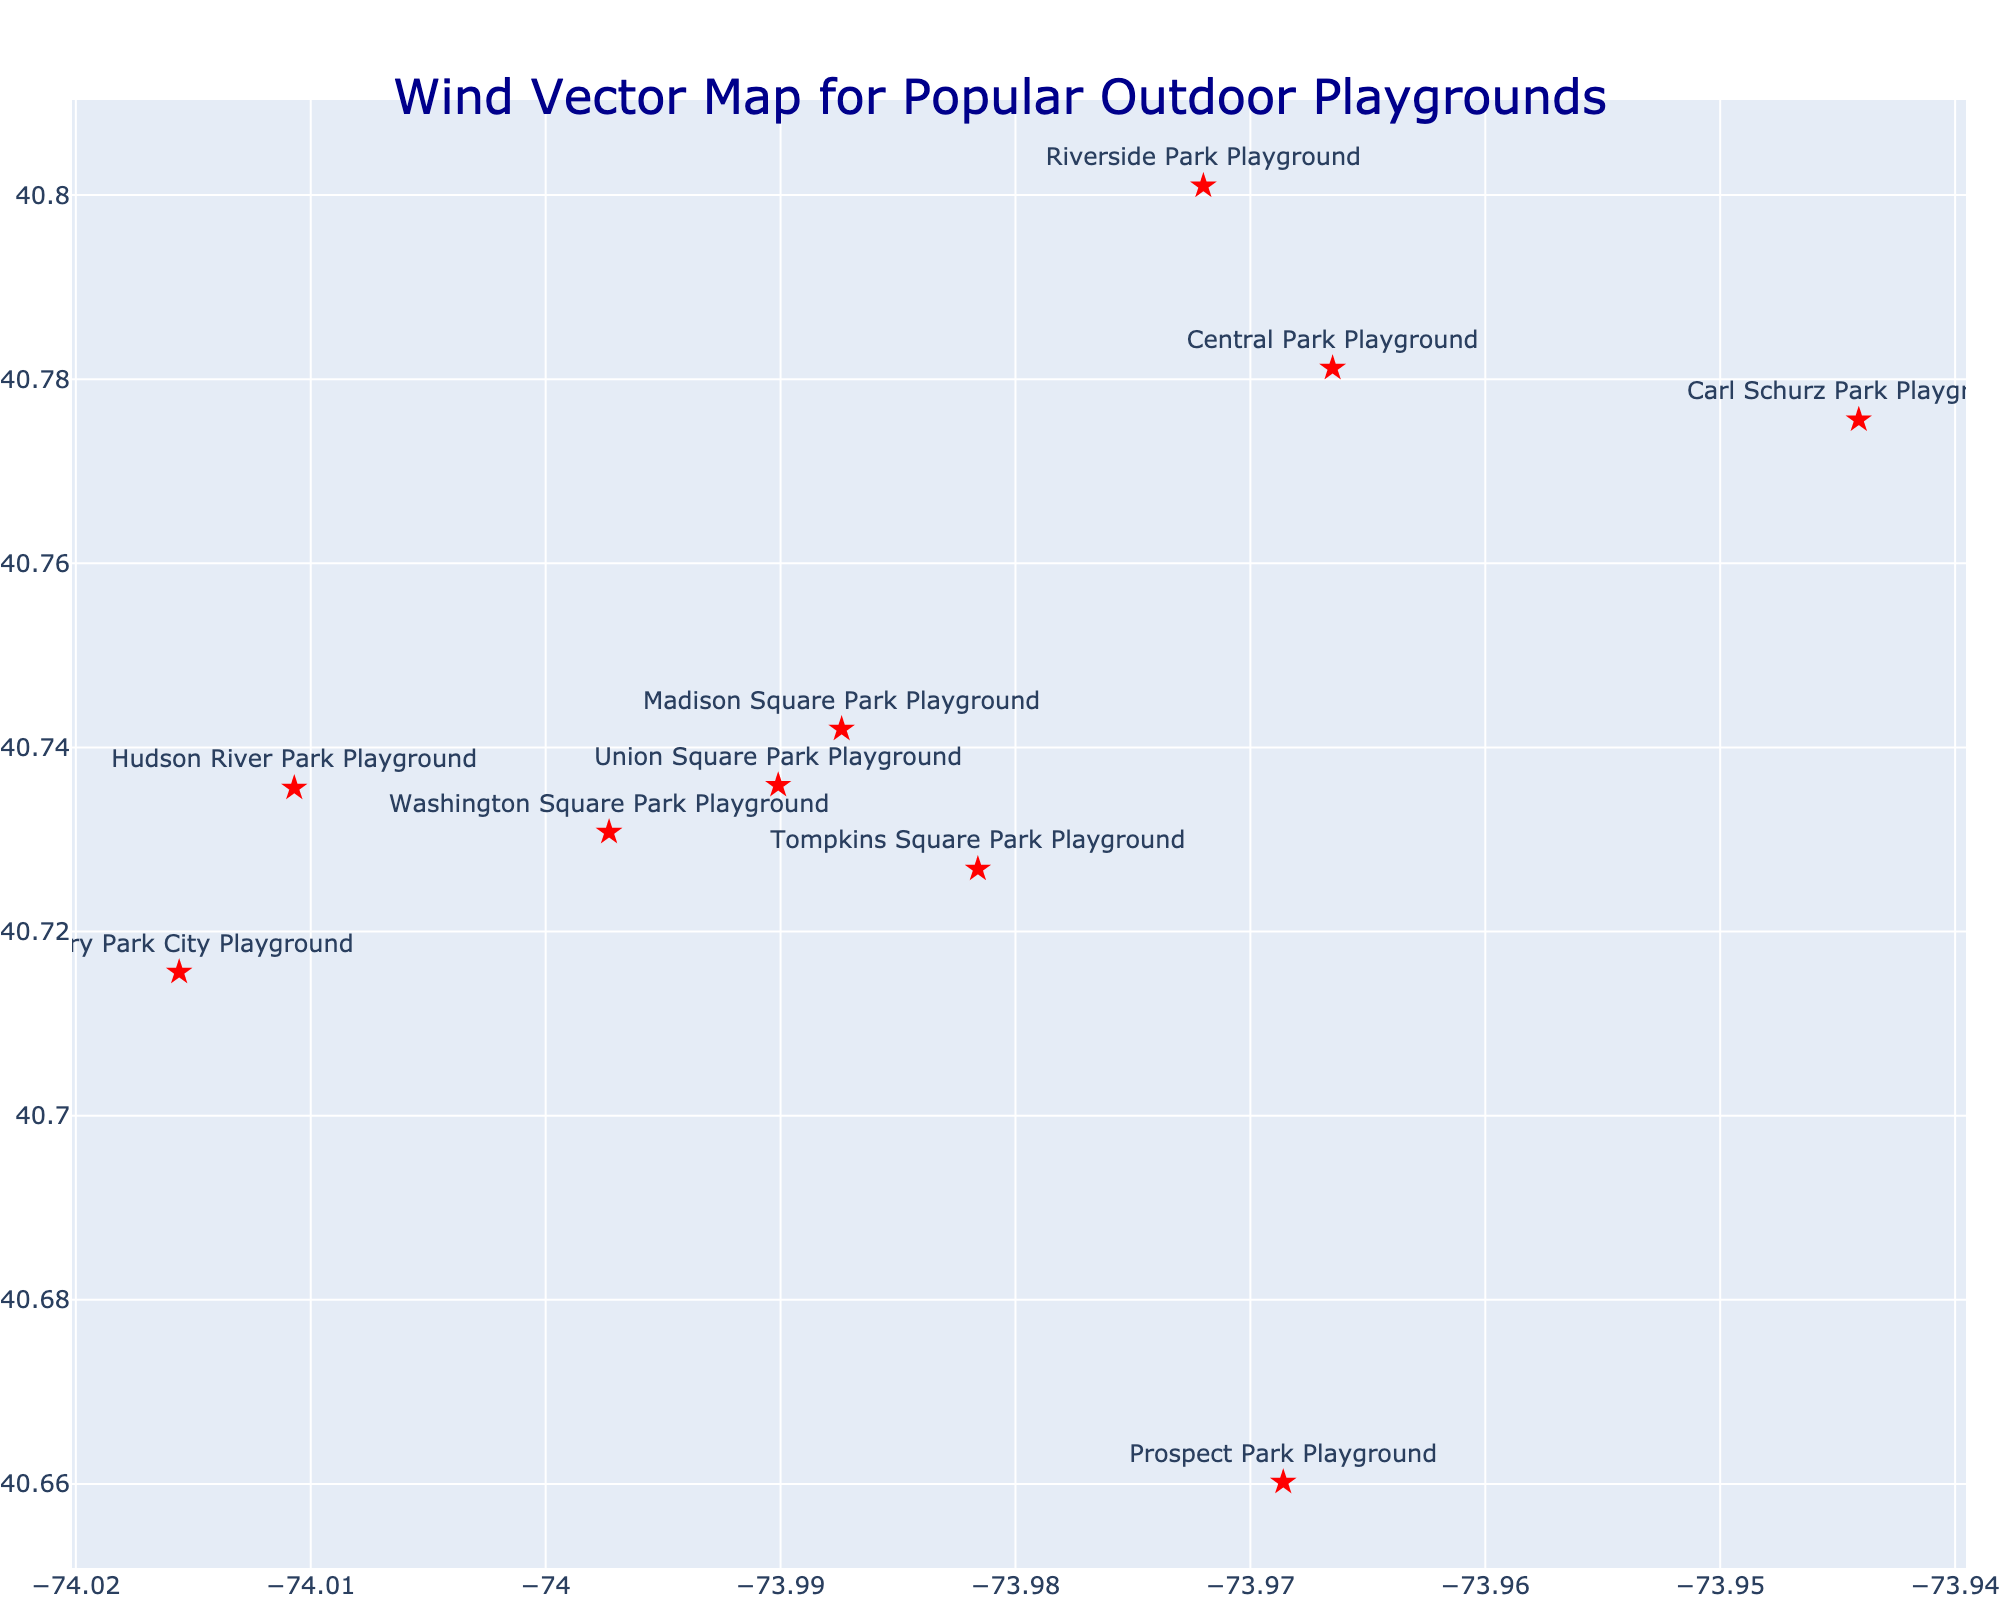What's the title of the figure? The title is usually displayed at the top of the figure. In this case, it's clearly stated in a larger font.
Answer: Wind Vector Map for Popular Outdoor Playgrounds Which playground has the highest wind speed? You can identify this by looking at the color and length of the wind vectors and the annotations showing wind speed. The longest and darkest vector often indicates the highest speed.
Answer: Battery Park City Playground What are the wind speeds at Central Park Playground and Union Square Park Playground? By examining the annotations or hover text near each playground, you can find their respective wind speeds.
Answer: 8 mph (Central Park), 11 mph (Union Square) Which playground has the wind blowing from the south? Look for the wind direction specified in the hover text or annotations.
Answer: Union Square Park Playground Is the wind stronger at Riverside Park Playground or Hudson River Park Playground? Compare the wind speeds indicated in the figure for both playgrounds.
Answer: Riverside Park Playground (12 mph) is stronger than Hudson River Park Playground (10 mph) What two playgrounds have wind coming from the northwest? Check the wind direction annotations or hover text to identify all playgrounds with a northwest wind direction.
Answer: Riverside Park Playground and Carl Schurz Park Playground Which playground has the lowest wind speed? Identify the playground with the shortest and lightest vector, or check the annotations for the lowest wind speed value.
Answer: Tompkins Square Park Playground What is the average wind speed of all the listed playgrounds? Sum all wind speeds and divide by the number of playgrounds: (8+12+15+6+10+7+9+11+5+13)/10.
Answer: 9.6 mph If you want to avoid the playgrounds with wind from the north or northwest, which ones should you avoid? Identify all playgrounds with wind directions 'N' or 'NW' from the annotations or hover text.
Answer: Riverside Park, Carl Schurz Park, and Madison Square Park What is the wind direction at Prospect Park Playground? Check the annotation or hover text near the playground for wind direction.
Answer: SW 